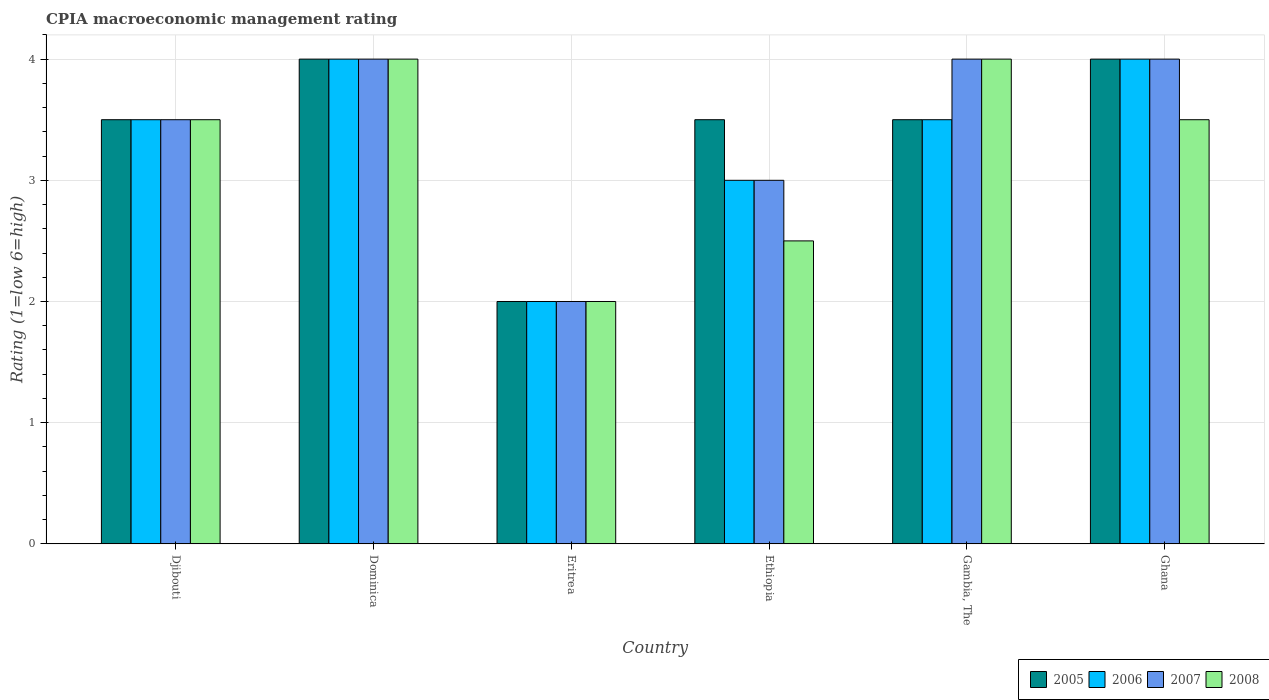How many groups of bars are there?
Ensure brevity in your answer.  6. Are the number of bars per tick equal to the number of legend labels?
Make the answer very short. Yes. How many bars are there on the 5th tick from the left?
Your answer should be compact. 4. How many bars are there on the 1st tick from the right?
Ensure brevity in your answer.  4. Across all countries, what is the maximum CPIA rating in 2005?
Your response must be concise. 4. Across all countries, what is the minimum CPIA rating in 2008?
Provide a succinct answer. 2. In which country was the CPIA rating in 2006 maximum?
Your answer should be very brief. Dominica. In which country was the CPIA rating in 2008 minimum?
Provide a succinct answer. Eritrea. What is the total CPIA rating in 2006 in the graph?
Provide a succinct answer. 20. What is the difference between the CPIA rating in 2008 in Dominica and that in Ethiopia?
Ensure brevity in your answer.  1.5. What is the difference between the CPIA rating in 2008 in Eritrea and the CPIA rating in 2006 in Ghana?
Your answer should be very brief. -2. What is the average CPIA rating in 2006 per country?
Make the answer very short. 3.33. What is the difference between the CPIA rating of/in 2005 and CPIA rating of/in 2006 in Gambia, The?
Give a very brief answer. 0. In how many countries, is the CPIA rating in 2006 greater than 2.8?
Offer a very short reply. 5. What is the ratio of the CPIA rating in 2005 in Eritrea to that in Ethiopia?
Make the answer very short. 0.57. Is the difference between the CPIA rating in 2005 in Ethiopia and Ghana greater than the difference between the CPIA rating in 2006 in Ethiopia and Ghana?
Make the answer very short. Yes. What is the difference between the highest and the lowest CPIA rating in 2005?
Provide a short and direct response. 2. In how many countries, is the CPIA rating in 2006 greater than the average CPIA rating in 2006 taken over all countries?
Provide a succinct answer. 4. What does the 2nd bar from the left in Ethiopia represents?
Offer a very short reply. 2006. Is it the case that in every country, the sum of the CPIA rating in 2006 and CPIA rating in 2005 is greater than the CPIA rating in 2007?
Your response must be concise. Yes. Are all the bars in the graph horizontal?
Your answer should be very brief. No. What is the difference between two consecutive major ticks on the Y-axis?
Provide a succinct answer. 1. Where does the legend appear in the graph?
Offer a very short reply. Bottom right. How many legend labels are there?
Provide a short and direct response. 4. How are the legend labels stacked?
Your answer should be compact. Horizontal. What is the title of the graph?
Your response must be concise. CPIA macroeconomic management rating. Does "1985" appear as one of the legend labels in the graph?
Give a very brief answer. No. What is the label or title of the Y-axis?
Provide a short and direct response. Rating (1=low 6=high). What is the Rating (1=low 6=high) of 2006 in Djibouti?
Give a very brief answer. 3.5. What is the Rating (1=low 6=high) in 2008 in Djibouti?
Your answer should be very brief. 3.5. What is the Rating (1=low 6=high) in 2006 in Dominica?
Provide a short and direct response. 4. What is the Rating (1=low 6=high) in 2008 in Dominica?
Offer a terse response. 4. What is the Rating (1=low 6=high) of 2005 in Eritrea?
Give a very brief answer. 2. What is the Rating (1=low 6=high) of 2005 in Ethiopia?
Your answer should be compact. 3.5. What is the Rating (1=low 6=high) of 2005 in Gambia, The?
Offer a very short reply. 3.5. What is the Rating (1=low 6=high) of 2007 in Gambia, The?
Provide a succinct answer. 4. What is the Rating (1=low 6=high) of 2008 in Gambia, The?
Provide a succinct answer. 4. What is the Rating (1=low 6=high) in 2006 in Ghana?
Your response must be concise. 4. What is the Rating (1=low 6=high) of 2007 in Ghana?
Keep it short and to the point. 4. What is the Rating (1=low 6=high) of 2008 in Ghana?
Provide a short and direct response. 3.5. Across all countries, what is the maximum Rating (1=low 6=high) in 2006?
Give a very brief answer. 4. Across all countries, what is the maximum Rating (1=low 6=high) in 2007?
Give a very brief answer. 4. Across all countries, what is the maximum Rating (1=low 6=high) in 2008?
Offer a terse response. 4. Across all countries, what is the minimum Rating (1=low 6=high) in 2005?
Offer a terse response. 2. Across all countries, what is the minimum Rating (1=low 6=high) of 2007?
Ensure brevity in your answer.  2. What is the total Rating (1=low 6=high) in 2006 in the graph?
Make the answer very short. 20. What is the difference between the Rating (1=low 6=high) of 2005 in Djibouti and that in Dominica?
Keep it short and to the point. -0.5. What is the difference between the Rating (1=low 6=high) in 2007 in Djibouti and that in Dominica?
Ensure brevity in your answer.  -0.5. What is the difference between the Rating (1=low 6=high) of 2005 in Djibouti and that in Eritrea?
Ensure brevity in your answer.  1.5. What is the difference between the Rating (1=low 6=high) of 2006 in Djibouti and that in Eritrea?
Your answer should be very brief. 1.5. What is the difference between the Rating (1=low 6=high) of 2007 in Djibouti and that in Eritrea?
Give a very brief answer. 1.5. What is the difference between the Rating (1=low 6=high) of 2008 in Djibouti and that in Eritrea?
Offer a terse response. 1.5. What is the difference between the Rating (1=low 6=high) in 2007 in Djibouti and that in Ethiopia?
Offer a terse response. 0.5. What is the difference between the Rating (1=low 6=high) of 2008 in Djibouti and that in Ethiopia?
Make the answer very short. 1. What is the difference between the Rating (1=low 6=high) of 2005 in Djibouti and that in Gambia, The?
Your response must be concise. 0. What is the difference between the Rating (1=low 6=high) of 2007 in Djibouti and that in Gambia, The?
Provide a succinct answer. -0.5. What is the difference between the Rating (1=low 6=high) in 2006 in Djibouti and that in Ghana?
Offer a very short reply. -0.5. What is the difference between the Rating (1=low 6=high) in 2007 in Djibouti and that in Ghana?
Provide a short and direct response. -0.5. What is the difference between the Rating (1=low 6=high) of 2008 in Djibouti and that in Ghana?
Provide a short and direct response. 0. What is the difference between the Rating (1=low 6=high) in 2006 in Dominica and that in Eritrea?
Offer a very short reply. 2. What is the difference between the Rating (1=low 6=high) in 2007 in Dominica and that in Eritrea?
Offer a very short reply. 2. What is the difference between the Rating (1=low 6=high) in 2005 in Dominica and that in Ethiopia?
Keep it short and to the point. 0.5. What is the difference between the Rating (1=low 6=high) of 2006 in Dominica and that in Ethiopia?
Make the answer very short. 1. What is the difference between the Rating (1=low 6=high) in 2007 in Dominica and that in Ethiopia?
Give a very brief answer. 1. What is the difference between the Rating (1=low 6=high) in 2006 in Dominica and that in Gambia, The?
Keep it short and to the point. 0.5. What is the difference between the Rating (1=low 6=high) in 2008 in Dominica and that in Gambia, The?
Keep it short and to the point. 0. What is the difference between the Rating (1=low 6=high) in 2005 in Dominica and that in Ghana?
Your answer should be compact. 0. What is the difference between the Rating (1=low 6=high) of 2006 in Dominica and that in Ghana?
Offer a very short reply. 0. What is the difference between the Rating (1=low 6=high) in 2008 in Dominica and that in Ghana?
Provide a succinct answer. 0.5. What is the difference between the Rating (1=low 6=high) of 2006 in Eritrea and that in Ethiopia?
Provide a short and direct response. -1. What is the difference between the Rating (1=low 6=high) of 2008 in Eritrea and that in Ethiopia?
Provide a succinct answer. -0.5. What is the difference between the Rating (1=low 6=high) in 2007 in Eritrea and that in Gambia, The?
Keep it short and to the point. -2. What is the difference between the Rating (1=low 6=high) of 2006 in Eritrea and that in Ghana?
Your answer should be very brief. -2. What is the difference between the Rating (1=low 6=high) in 2007 in Eritrea and that in Ghana?
Give a very brief answer. -2. What is the difference between the Rating (1=low 6=high) of 2008 in Eritrea and that in Ghana?
Keep it short and to the point. -1.5. What is the difference between the Rating (1=low 6=high) of 2006 in Ethiopia and that in Gambia, The?
Your answer should be very brief. -0.5. What is the difference between the Rating (1=low 6=high) of 2007 in Ethiopia and that in Gambia, The?
Offer a terse response. -1. What is the difference between the Rating (1=low 6=high) of 2008 in Ethiopia and that in Gambia, The?
Make the answer very short. -1.5. What is the difference between the Rating (1=low 6=high) of 2007 in Ethiopia and that in Ghana?
Your answer should be compact. -1. What is the difference between the Rating (1=low 6=high) of 2008 in Ethiopia and that in Ghana?
Give a very brief answer. -1. What is the difference between the Rating (1=low 6=high) of 2007 in Gambia, The and that in Ghana?
Your answer should be very brief. 0. What is the difference between the Rating (1=low 6=high) of 2008 in Gambia, The and that in Ghana?
Your answer should be very brief. 0.5. What is the difference between the Rating (1=low 6=high) in 2005 in Djibouti and the Rating (1=low 6=high) in 2007 in Dominica?
Your answer should be very brief. -0.5. What is the difference between the Rating (1=low 6=high) of 2006 in Djibouti and the Rating (1=low 6=high) of 2007 in Dominica?
Your response must be concise. -0.5. What is the difference between the Rating (1=low 6=high) in 2007 in Djibouti and the Rating (1=low 6=high) in 2008 in Dominica?
Offer a terse response. -0.5. What is the difference between the Rating (1=low 6=high) of 2005 in Djibouti and the Rating (1=low 6=high) of 2006 in Ethiopia?
Your answer should be compact. 0.5. What is the difference between the Rating (1=low 6=high) in 2005 in Djibouti and the Rating (1=low 6=high) in 2007 in Ethiopia?
Make the answer very short. 0.5. What is the difference between the Rating (1=low 6=high) in 2005 in Djibouti and the Rating (1=low 6=high) in 2008 in Ethiopia?
Make the answer very short. 1. What is the difference between the Rating (1=low 6=high) of 2005 in Djibouti and the Rating (1=low 6=high) of 2006 in Gambia, The?
Provide a succinct answer. 0. What is the difference between the Rating (1=low 6=high) of 2005 in Djibouti and the Rating (1=low 6=high) of 2008 in Gambia, The?
Your response must be concise. -0.5. What is the difference between the Rating (1=low 6=high) of 2006 in Djibouti and the Rating (1=low 6=high) of 2008 in Gambia, The?
Make the answer very short. -0.5. What is the difference between the Rating (1=low 6=high) of 2007 in Djibouti and the Rating (1=low 6=high) of 2008 in Gambia, The?
Your answer should be compact. -0.5. What is the difference between the Rating (1=low 6=high) of 2005 in Djibouti and the Rating (1=low 6=high) of 2006 in Ghana?
Provide a short and direct response. -0.5. What is the difference between the Rating (1=low 6=high) of 2005 in Djibouti and the Rating (1=low 6=high) of 2008 in Ghana?
Your answer should be very brief. 0. What is the difference between the Rating (1=low 6=high) in 2005 in Dominica and the Rating (1=low 6=high) in 2006 in Eritrea?
Provide a succinct answer. 2. What is the difference between the Rating (1=low 6=high) of 2005 in Dominica and the Rating (1=low 6=high) of 2007 in Eritrea?
Provide a short and direct response. 2. What is the difference between the Rating (1=low 6=high) in 2005 in Dominica and the Rating (1=low 6=high) in 2008 in Eritrea?
Offer a very short reply. 2. What is the difference between the Rating (1=low 6=high) in 2006 in Dominica and the Rating (1=low 6=high) in 2008 in Eritrea?
Provide a succinct answer. 2. What is the difference between the Rating (1=low 6=high) of 2007 in Dominica and the Rating (1=low 6=high) of 2008 in Eritrea?
Your response must be concise. 2. What is the difference between the Rating (1=low 6=high) of 2005 in Dominica and the Rating (1=low 6=high) of 2006 in Ethiopia?
Your answer should be compact. 1. What is the difference between the Rating (1=low 6=high) of 2007 in Dominica and the Rating (1=low 6=high) of 2008 in Ethiopia?
Your answer should be compact. 1.5. What is the difference between the Rating (1=low 6=high) in 2005 in Dominica and the Rating (1=low 6=high) in 2006 in Gambia, The?
Your answer should be very brief. 0.5. What is the difference between the Rating (1=low 6=high) of 2006 in Dominica and the Rating (1=low 6=high) of 2007 in Gambia, The?
Keep it short and to the point. 0. What is the difference between the Rating (1=low 6=high) of 2006 in Dominica and the Rating (1=low 6=high) of 2008 in Gambia, The?
Give a very brief answer. 0. What is the difference between the Rating (1=low 6=high) in 2005 in Dominica and the Rating (1=low 6=high) in 2007 in Ghana?
Offer a terse response. 0. What is the difference between the Rating (1=low 6=high) of 2006 in Dominica and the Rating (1=low 6=high) of 2007 in Ghana?
Your answer should be compact. 0. What is the difference between the Rating (1=low 6=high) in 2007 in Dominica and the Rating (1=low 6=high) in 2008 in Ghana?
Make the answer very short. 0.5. What is the difference between the Rating (1=low 6=high) of 2005 in Eritrea and the Rating (1=low 6=high) of 2007 in Ethiopia?
Offer a very short reply. -1. What is the difference between the Rating (1=low 6=high) in 2005 in Eritrea and the Rating (1=low 6=high) in 2006 in Gambia, The?
Give a very brief answer. -1.5. What is the difference between the Rating (1=low 6=high) in 2005 in Eritrea and the Rating (1=low 6=high) in 2008 in Gambia, The?
Keep it short and to the point. -2. What is the difference between the Rating (1=low 6=high) in 2005 in Eritrea and the Rating (1=low 6=high) in 2006 in Ghana?
Offer a very short reply. -2. What is the difference between the Rating (1=low 6=high) in 2005 in Eritrea and the Rating (1=low 6=high) in 2007 in Ghana?
Keep it short and to the point. -2. What is the difference between the Rating (1=low 6=high) of 2005 in Eritrea and the Rating (1=low 6=high) of 2008 in Ghana?
Offer a terse response. -1.5. What is the difference between the Rating (1=low 6=high) of 2006 in Eritrea and the Rating (1=low 6=high) of 2007 in Ghana?
Your answer should be very brief. -2. What is the difference between the Rating (1=low 6=high) of 2007 in Eritrea and the Rating (1=low 6=high) of 2008 in Ghana?
Keep it short and to the point. -1.5. What is the difference between the Rating (1=low 6=high) of 2005 in Ethiopia and the Rating (1=low 6=high) of 2007 in Gambia, The?
Your answer should be compact. -0.5. What is the difference between the Rating (1=low 6=high) in 2005 in Ethiopia and the Rating (1=low 6=high) in 2008 in Gambia, The?
Ensure brevity in your answer.  -0.5. What is the difference between the Rating (1=low 6=high) of 2006 in Ethiopia and the Rating (1=low 6=high) of 2008 in Gambia, The?
Provide a short and direct response. -1. What is the difference between the Rating (1=low 6=high) of 2005 in Ethiopia and the Rating (1=low 6=high) of 2006 in Ghana?
Offer a very short reply. -0.5. What is the difference between the Rating (1=low 6=high) in 2005 in Ethiopia and the Rating (1=low 6=high) in 2007 in Ghana?
Provide a short and direct response. -0.5. What is the difference between the Rating (1=low 6=high) of 2005 in Ethiopia and the Rating (1=low 6=high) of 2008 in Ghana?
Ensure brevity in your answer.  0. What is the difference between the Rating (1=low 6=high) in 2006 in Ethiopia and the Rating (1=low 6=high) in 2007 in Ghana?
Give a very brief answer. -1. What is the difference between the Rating (1=low 6=high) of 2006 in Ethiopia and the Rating (1=low 6=high) of 2008 in Ghana?
Ensure brevity in your answer.  -0.5. What is the difference between the Rating (1=low 6=high) of 2007 in Ethiopia and the Rating (1=low 6=high) of 2008 in Ghana?
Offer a terse response. -0.5. What is the difference between the Rating (1=low 6=high) of 2005 in Gambia, The and the Rating (1=low 6=high) of 2008 in Ghana?
Offer a terse response. 0. What is the difference between the Rating (1=low 6=high) of 2006 in Gambia, The and the Rating (1=low 6=high) of 2007 in Ghana?
Offer a terse response. -0.5. What is the difference between the Rating (1=low 6=high) of 2006 in Gambia, The and the Rating (1=low 6=high) of 2008 in Ghana?
Offer a very short reply. 0. What is the average Rating (1=low 6=high) in 2005 per country?
Ensure brevity in your answer.  3.42. What is the average Rating (1=low 6=high) in 2006 per country?
Ensure brevity in your answer.  3.33. What is the average Rating (1=low 6=high) in 2007 per country?
Make the answer very short. 3.42. What is the average Rating (1=low 6=high) in 2008 per country?
Ensure brevity in your answer.  3.25. What is the difference between the Rating (1=low 6=high) in 2005 and Rating (1=low 6=high) in 2006 in Djibouti?
Offer a very short reply. 0. What is the difference between the Rating (1=low 6=high) of 2005 and Rating (1=low 6=high) of 2008 in Djibouti?
Make the answer very short. 0. What is the difference between the Rating (1=low 6=high) in 2006 and Rating (1=low 6=high) in 2008 in Djibouti?
Give a very brief answer. 0. What is the difference between the Rating (1=low 6=high) in 2005 and Rating (1=low 6=high) in 2006 in Dominica?
Your answer should be very brief. 0. What is the difference between the Rating (1=low 6=high) in 2007 and Rating (1=low 6=high) in 2008 in Dominica?
Offer a terse response. 0. What is the difference between the Rating (1=low 6=high) in 2005 and Rating (1=low 6=high) in 2006 in Eritrea?
Your answer should be compact. 0. What is the difference between the Rating (1=low 6=high) in 2005 and Rating (1=low 6=high) in 2007 in Eritrea?
Your answer should be very brief. 0. What is the difference between the Rating (1=low 6=high) of 2005 and Rating (1=low 6=high) of 2008 in Eritrea?
Offer a terse response. 0. What is the difference between the Rating (1=low 6=high) in 2006 and Rating (1=low 6=high) in 2008 in Eritrea?
Offer a terse response. 0. What is the difference between the Rating (1=low 6=high) in 2005 and Rating (1=low 6=high) in 2008 in Ethiopia?
Provide a succinct answer. 1. What is the difference between the Rating (1=low 6=high) in 2006 and Rating (1=low 6=high) in 2007 in Ethiopia?
Your answer should be compact. 0. What is the difference between the Rating (1=low 6=high) of 2006 and Rating (1=low 6=high) of 2007 in Gambia, The?
Provide a succinct answer. -0.5. What is the difference between the Rating (1=low 6=high) in 2006 and Rating (1=low 6=high) in 2008 in Gambia, The?
Your answer should be very brief. -0.5. What is the difference between the Rating (1=low 6=high) of 2005 and Rating (1=low 6=high) of 2006 in Ghana?
Your answer should be compact. 0. What is the difference between the Rating (1=low 6=high) of 2005 and Rating (1=low 6=high) of 2008 in Ghana?
Your response must be concise. 0.5. What is the ratio of the Rating (1=low 6=high) of 2005 in Djibouti to that in Dominica?
Give a very brief answer. 0.88. What is the ratio of the Rating (1=low 6=high) of 2006 in Djibouti to that in Dominica?
Your answer should be very brief. 0.88. What is the ratio of the Rating (1=low 6=high) in 2008 in Djibouti to that in Dominica?
Your answer should be compact. 0.88. What is the ratio of the Rating (1=low 6=high) in 2005 in Djibouti to that in Eritrea?
Your response must be concise. 1.75. What is the ratio of the Rating (1=low 6=high) in 2007 in Djibouti to that in Eritrea?
Your answer should be compact. 1.75. What is the ratio of the Rating (1=low 6=high) of 2005 in Djibouti to that in Ethiopia?
Your answer should be compact. 1. What is the ratio of the Rating (1=low 6=high) in 2008 in Djibouti to that in Ethiopia?
Give a very brief answer. 1.4. What is the ratio of the Rating (1=low 6=high) of 2005 in Djibouti to that in Gambia, The?
Give a very brief answer. 1. What is the ratio of the Rating (1=low 6=high) of 2006 in Djibouti to that in Gambia, The?
Your answer should be very brief. 1. What is the ratio of the Rating (1=low 6=high) of 2007 in Djibouti to that in Gambia, The?
Offer a terse response. 0.88. What is the ratio of the Rating (1=low 6=high) of 2006 in Djibouti to that in Ghana?
Your answer should be compact. 0.88. What is the ratio of the Rating (1=low 6=high) in 2007 in Djibouti to that in Ghana?
Provide a succinct answer. 0.88. What is the ratio of the Rating (1=low 6=high) of 2007 in Dominica to that in Eritrea?
Make the answer very short. 2. What is the ratio of the Rating (1=low 6=high) of 2008 in Dominica to that in Eritrea?
Your answer should be compact. 2. What is the ratio of the Rating (1=low 6=high) in 2005 in Dominica to that in Ethiopia?
Your answer should be very brief. 1.14. What is the ratio of the Rating (1=low 6=high) of 2006 in Dominica to that in Ethiopia?
Provide a succinct answer. 1.33. What is the ratio of the Rating (1=low 6=high) in 2005 in Dominica to that in Gambia, The?
Your answer should be very brief. 1.14. What is the ratio of the Rating (1=low 6=high) in 2007 in Dominica to that in Gambia, The?
Your answer should be compact. 1. What is the ratio of the Rating (1=low 6=high) of 2008 in Dominica to that in Ghana?
Provide a succinct answer. 1.14. What is the ratio of the Rating (1=low 6=high) in 2005 in Eritrea to that in Ethiopia?
Keep it short and to the point. 0.57. What is the ratio of the Rating (1=low 6=high) of 2007 in Eritrea to that in Ethiopia?
Give a very brief answer. 0.67. What is the ratio of the Rating (1=low 6=high) in 2007 in Eritrea to that in Gambia, The?
Your response must be concise. 0.5. What is the ratio of the Rating (1=low 6=high) in 2005 in Eritrea to that in Ghana?
Make the answer very short. 0.5. What is the ratio of the Rating (1=low 6=high) in 2006 in Eritrea to that in Ghana?
Give a very brief answer. 0.5. What is the ratio of the Rating (1=low 6=high) of 2008 in Eritrea to that in Ghana?
Your answer should be very brief. 0.57. What is the ratio of the Rating (1=low 6=high) of 2005 in Ethiopia to that in Gambia, The?
Give a very brief answer. 1. What is the ratio of the Rating (1=low 6=high) of 2006 in Ethiopia to that in Gambia, The?
Keep it short and to the point. 0.86. What is the ratio of the Rating (1=low 6=high) of 2005 in Ethiopia to that in Ghana?
Your response must be concise. 0.88. What is the ratio of the Rating (1=low 6=high) in 2006 in Ethiopia to that in Ghana?
Your answer should be very brief. 0.75. What is the ratio of the Rating (1=low 6=high) of 2008 in Ethiopia to that in Ghana?
Your response must be concise. 0.71. What is the ratio of the Rating (1=low 6=high) in 2006 in Gambia, The to that in Ghana?
Your response must be concise. 0.88. What is the ratio of the Rating (1=low 6=high) in 2007 in Gambia, The to that in Ghana?
Your response must be concise. 1. What is the ratio of the Rating (1=low 6=high) of 2008 in Gambia, The to that in Ghana?
Your response must be concise. 1.14. What is the difference between the highest and the lowest Rating (1=low 6=high) of 2005?
Keep it short and to the point. 2. What is the difference between the highest and the lowest Rating (1=low 6=high) in 2006?
Keep it short and to the point. 2. 